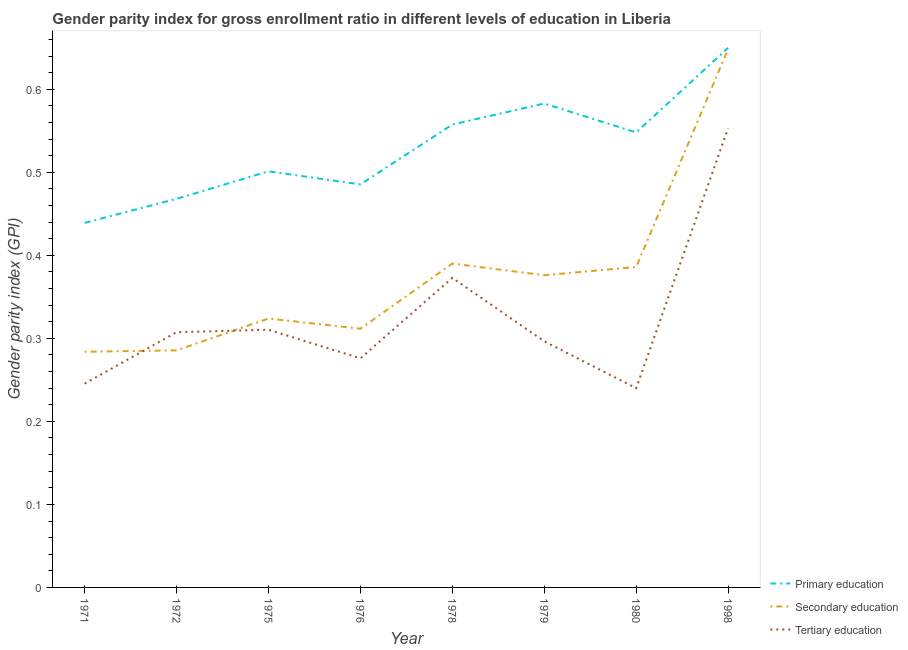Is the number of lines equal to the number of legend labels?
Offer a terse response. Yes. What is the gender parity index in primary education in 1978?
Your answer should be very brief. 0.56. Across all years, what is the maximum gender parity index in primary education?
Ensure brevity in your answer.  0.65. Across all years, what is the minimum gender parity index in secondary education?
Provide a succinct answer. 0.28. In which year was the gender parity index in tertiary education maximum?
Give a very brief answer. 1998. What is the total gender parity index in secondary education in the graph?
Your answer should be very brief. 3.01. What is the difference between the gender parity index in primary education in 1975 and that in 1978?
Your answer should be compact. -0.06. What is the difference between the gender parity index in tertiary education in 1980 and the gender parity index in secondary education in 1975?
Keep it short and to the point. -0.08. What is the average gender parity index in tertiary education per year?
Give a very brief answer. 0.33. In the year 1972, what is the difference between the gender parity index in primary education and gender parity index in secondary education?
Offer a very short reply. 0.18. What is the ratio of the gender parity index in secondary education in 1972 to that in 1978?
Provide a succinct answer. 0.73. Is the difference between the gender parity index in tertiary education in 1975 and 1978 greater than the difference between the gender parity index in secondary education in 1975 and 1978?
Your answer should be compact. Yes. What is the difference between the highest and the second highest gender parity index in primary education?
Provide a succinct answer. 0.07. What is the difference between the highest and the lowest gender parity index in tertiary education?
Offer a very short reply. 0.31. In how many years, is the gender parity index in secondary education greater than the average gender parity index in secondary education taken over all years?
Offer a terse response. 4. Is the sum of the gender parity index in primary education in 1972 and 1978 greater than the maximum gender parity index in tertiary education across all years?
Your answer should be compact. Yes. Is the gender parity index in secondary education strictly greater than the gender parity index in primary education over the years?
Give a very brief answer. No. Is the gender parity index in tertiary education strictly less than the gender parity index in primary education over the years?
Your answer should be compact. Yes. Does the graph contain any zero values?
Your answer should be very brief. No. Where does the legend appear in the graph?
Give a very brief answer. Bottom right. How many legend labels are there?
Ensure brevity in your answer.  3. What is the title of the graph?
Ensure brevity in your answer.  Gender parity index for gross enrollment ratio in different levels of education in Liberia. Does "Other sectors" appear as one of the legend labels in the graph?
Offer a very short reply. No. What is the label or title of the Y-axis?
Offer a terse response. Gender parity index (GPI). What is the Gender parity index (GPI) of Primary education in 1971?
Make the answer very short. 0.44. What is the Gender parity index (GPI) of Secondary education in 1971?
Provide a short and direct response. 0.28. What is the Gender parity index (GPI) in Tertiary education in 1971?
Offer a terse response. 0.25. What is the Gender parity index (GPI) of Primary education in 1972?
Offer a very short reply. 0.47. What is the Gender parity index (GPI) of Secondary education in 1972?
Provide a short and direct response. 0.29. What is the Gender parity index (GPI) in Tertiary education in 1972?
Your answer should be compact. 0.31. What is the Gender parity index (GPI) of Primary education in 1975?
Make the answer very short. 0.5. What is the Gender parity index (GPI) of Secondary education in 1975?
Your answer should be very brief. 0.32. What is the Gender parity index (GPI) of Tertiary education in 1975?
Provide a succinct answer. 0.31. What is the Gender parity index (GPI) of Primary education in 1976?
Ensure brevity in your answer.  0.49. What is the Gender parity index (GPI) of Secondary education in 1976?
Make the answer very short. 0.31. What is the Gender parity index (GPI) in Tertiary education in 1976?
Your answer should be very brief. 0.28. What is the Gender parity index (GPI) of Primary education in 1978?
Your answer should be very brief. 0.56. What is the Gender parity index (GPI) in Secondary education in 1978?
Keep it short and to the point. 0.39. What is the Gender parity index (GPI) of Tertiary education in 1978?
Make the answer very short. 0.37. What is the Gender parity index (GPI) of Primary education in 1979?
Make the answer very short. 0.58. What is the Gender parity index (GPI) of Secondary education in 1979?
Give a very brief answer. 0.38. What is the Gender parity index (GPI) of Tertiary education in 1979?
Ensure brevity in your answer.  0.3. What is the Gender parity index (GPI) in Primary education in 1980?
Provide a succinct answer. 0.55. What is the Gender parity index (GPI) of Secondary education in 1980?
Provide a short and direct response. 0.39. What is the Gender parity index (GPI) in Tertiary education in 1980?
Your response must be concise. 0.24. What is the Gender parity index (GPI) of Primary education in 1998?
Ensure brevity in your answer.  0.65. What is the Gender parity index (GPI) of Secondary education in 1998?
Provide a short and direct response. 0.65. What is the Gender parity index (GPI) of Tertiary education in 1998?
Keep it short and to the point. 0.55. Across all years, what is the maximum Gender parity index (GPI) of Primary education?
Offer a very short reply. 0.65. Across all years, what is the maximum Gender parity index (GPI) in Secondary education?
Ensure brevity in your answer.  0.65. Across all years, what is the maximum Gender parity index (GPI) in Tertiary education?
Your answer should be very brief. 0.55. Across all years, what is the minimum Gender parity index (GPI) in Primary education?
Give a very brief answer. 0.44. Across all years, what is the minimum Gender parity index (GPI) in Secondary education?
Ensure brevity in your answer.  0.28. Across all years, what is the minimum Gender parity index (GPI) of Tertiary education?
Offer a very short reply. 0.24. What is the total Gender parity index (GPI) in Primary education in the graph?
Make the answer very short. 4.23. What is the total Gender parity index (GPI) of Secondary education in the graph?
Offer a very short reply. 3.01. What is the total Gender parity index (GPI) in Tertiary education in the graph?
Ensure brevity in your answer.  2.6. What is the difference between the Gender parity index (GPI) of Primary education in 1971 and that in 1972?
Your response must be concise. -0.03. What is the difference between the Gender parity index (GPI) of Secondary education in 1971 and that in 1972?
Provide a succinct answer. -0. What is the difference between the Gender parity index (GPI) in Tertiary education in 1971 and that in 1972?
Your answer should be very brief. -0.06. What is the difference between the Gender parity index (GPI) of Primary education in 1971 and that in 1975?
Your answer should be very brief. -0.06. What is the difference between the Gender parity index (GPI) in Secondary education in 1971 and that in 1975?
Provide a short and direct response. -0.04. What is the difference between the Gender parity index (GPI) of Tertiary education in 1971 and that in 1975?
Offer a terse response. -0.06. What is the difference between the Gender parity index (GPI) in Primary education in 1971 and that in 1976?
Give a very brief answer. -0.05. What is the difference between the Gender parity index (GPI) in Secondary education in 1971 and that in 1976?
Your answer should be very brief. -0.03. What is the difference between the Gender parity index (GPI) of Tertiary education in 1971 and that in 1976?
Offer a very short reply. -0.03. What is the difference between the Gender parity index (GPI) of Primary education in 1971 and that in 1978?
Your response must be concise. -0.12. What is the difference between the Gender parity index (GPI) of Secondary education in 1971 and that in 1978?
Offer a terse response. -0.11. What is the difference between the Gender parity index (GPI) in Tertiary education in 1971 and that in 1978?
Ensure brevity in your answer.  -0.13. What is the difference between the Gender parity index (GPI) of Primary education in 1971 and that in 1979?
Your answer should be compact. -0.14. What is the difference between the Gender parity index (GPI) of Secondary education in 1971 and that in 1979?
Your response must be concise. -0.09. What is the difference between the Gender parity index (GPI) of Tertiary education in 1971 and that in 1979?
Provide a short and direct response. -0.05. What is the difference between the Gender parity index (GPI) in Primary education in 1971 and that in 1980?
Keep it short and to the point. -0.11. What is the difference between the Gender parity index (GPI) in Secondary education in 1971 and that in 1980?
Ensure brevity in your answer.  -0.1. What is the difference between the Gender parity index (GPI) of Tertiary education in 1971 and that in 1980?
Ensure brevity in your answer.  0.01. What is the difference between the Gender parity index (GPI) of Primary education in 1971 and that in 1998?
Your response must be concise. -0.21. What is the difference between the Gender parity index (GPI) in Secondary education in 1971 and that in 1998?
Provide a short and direct response. -0.36. What is the difference between the Gender parity index (GPI) of Tertiary education in 1971 and that in 1998?
Give a very brief answer. -0.31. What is the difference between the Gender parity index (GPI) in Primary education in 1972 and that in 1975?
Provide a succinct answer. -0.03. What is the difference between the Gender parity index (GPI) of Secondary education in 1972 and that in 1975?
Your response must be concise. -0.04. What is the difference between the Gender parity index (GPI) of Tertiary education in 1972 and that in 1975?
Ensure brevity in your answer.  -0. What is the difference between the Gender parity index (GPI) in Primary education in 1972 and that in 1976?
Offer a very short reply. -0.02. What is the difference between the Gender parity index (GPI) of Secondary education in 1972 and that in 1976?
Offer a very short reply. -0.03. What is the difference between the Gender parity index (GPI) in Tertiary education in 1972 and that in 1976?
Your response must be concise. 0.03. What is the difference between the Gender parity index (GPI) in Primary education in 1972 and that in 1978?
Provide a succinct answer. -0.09. What is the difference between the Gender parity index (GPI) in Secondary education in 1972 and that in 1978?
Make the answer very short. -0.1. What is the difference between the Gender parity index (GPI) of Tertiary education in 1972 and that in 1978?
Give a very brief answer. -0.07. What is the difference between the Gender parity index (GPI) in Primary education in 1972 and that in 1979?
Provide a short and direct response. -0.11. What is the difference between the Gender parity index (GPI) of Secondary education in 1972 and that in 1979?
Make the answer very short. -0.09. What is the difference between the Gender parity index (GPI) in Tertiary education in 1972 and that in 1979?
Provide a short and direct response. 0.01. What is the difference between the Gender parity index (GPI) in Primary education in 1972 and that in 1980?
Make the answer very short. -0.08. What is the difference between the Gender parity index (GPI) in Secondary education in 1972 and that in 1980?
Provide a short and direct response. -0.1. What is the difference between the Gender parity index (GPI) of Tertiary education in 1972 and that in 1980?
Offer a very short reply. 0.07. What is the difference between the Gender parity index (GPI) in Primary education in 1972 and that in 1998?
Keep it short and to the point. -0.18. What is the difference between the Gender parity index (GPI) of Secondary education in 1972 and that in 1998?
Give a very brief answer. -0.36. What is the difference between the Gender parity index (GPI) of Tertiary education in 1972 and that in 1998?
Make the answer very short. -0.25. What is the difference between the Gender parity index (GPI) in Primary education in 1975 and that in 1976?
Your response must be concise. 0.02. What is the difference between the Gender parity index (GPI) of Secondary education in 1975 and that in 1976?
Offer a terse response. 0.01. What is the difference between the Gender parity index (GPI) of Tertiary education in 1975 and that in 1976?
Your response must be concise. 0.03. What is the difference between the Gender parity index (GPI) in Primary education in 1975 and that in 1978?
Provide a short and direct response. -0.06. What is the difference between the Gender parity index (GPI) of Secondary education in 1975 and that in 1978?
Ensure brevity in your answer.  -0.07. What is the difference between the Gender parity index (GPI) in Tertiary education in 1975 and that in 1978?
Your response must be concise. -0.06. What is the difference between the Gender parity index (GPI) of Primary education in 1975 and that in 1979?
Your answer should be compact. -0.08. What is the difference between the Gender parity index (GPI) of Secondary education in 1975 and that in 1979?
Give a very brief answer. -0.05. What is the difference between the Gender parity index (GPI) of Tertiary education in 1975 and that in 1979?
Make the answer very short. 0.01. What is the difference between the Gender parity index (GPI) of Primary education in 1975 and that in 1980?
Your answer should be compact. -0.05. What is the difference between the Gender parity index (GPI) of Secondary education in 1975 and that in 1980?
Keep it short and to the point. -0.06. What is the difference between the Gender parity index (GPI) of Tertiary education in 1975 and that in 1980?
Offer a very short reply. 0.07. What is the difference between the Gender parity index (GPI) of Primary education in 1975 and that in 1998?
Ensure brevity in your answer.  -0.15. What is the difference between the Gender parity index (GPI) in Secondary education in 1975 and that in 1998?
Offer a very short reply. -0.32. What is the difference between the Gender parity index (GPI) in Tertiary education in 1975 and that in 1998?
Offer a terse response. -0.24. What is the difference between the Gender parity index (GPI) in Primary education in 1976 and that in 1978?
Your answer should be compact. -0.07. What is the difference between the Gender parity index (GPI) of Secondary education in 1976 and that in 1978?
Your answer should be compact. -0.08. What is the difference between the Gender parity index (GPI) of Tertiary education in 1976 and that in 1978?
Your answer should be compact. -0.1. What is the difference between the Gender parity index (GPI) of Primary education in 1976 and that in 1979?
Ensure brevity in your answer.  -0.1. What is the difference between the Gender parity index (GPI) in Secondary education in 1976 and that in 1979?
Offer a terse response. -0.06. What is the difference between the Gender parity index (GPI) in Tertiary education in 1976 and that in 1979?
Your answer should be very brief. -0.02. What is the difference between the Gender parity index (GPI) of Primary education in 1976 and that in 1980?
Give a very brief answer. -0.06. What is the difference between the Gender parity index (GPI) in Secondary education in 1976 and that in 1980?
Your answer should be compact. -0.07. What is the difference between the Gender parity index (GPI) of Tertiary education in 1976 and that in 1980?
Provide a succinct answer. 0.04. What is the difference between the Gender parity index (GPI) in Primary education in 1976 and that in 1998?
Provide a short and direct response. -0.16. What is the difference between the Gender parity index (GPI) in Secondary education in 1976 and that in 1998?
Keep it short and to the point. -0.34. What is the difference between the Gender parity index (GPI) in Tertiary education in 1976 and that in 1998?
Provide a short and direct response. -0.28. What is the difference between the Gender parity index (GPI) in Primary education in 1978 and that in 1979?
Ensure brevity in your answer.  -0.03. What is the difference between the Gender parity index (GPI) of Secondary education in 1978 and that in 1979?
Offer a very short reply. 0.01. What is the difference between the Gender parity index (GPI) of Tertiary education in 1978 and that in 1979?
Provide a succinct answer. 0.08. What is the difference between the Gender parity index (GPI) of Primary education in 1978 and that in 1980?
Your answer should be very brief. 0.01. What is the difference between the Gender parity index (GPI) in Secondary education in 1978 and that in 1980?
Ensure brevity in your answer.  0. What is the difference between the Gender parity index (GPI) of Tertiary education in 1978 and that in 1980?
Offer a very short reply. 0.13. What is the difference between the Gender parity index (GPI) in Primary education in 1978 and that in 1998?
Provide a succinct answer. -0.09. What is the difference between the Gender parity index (GPI) in Secondary education in 1978 and that in 1998?
Keep it short and to the point. -0.26. What is the difference between the Gender parity index (GPI) in Tertiary education in 1978 and that in 1998?
Provide a succinct answer. -0.18. What is the difference between the Gender parity index (GPI) in Primary education in 1979 and that in 1980?
Provide a short and direct response. 0.03. What is the difference between the Gender parity index (GPI) of Secondary education in 1979 and that in 1980?
Give a very brief answer. -0.01. What is the difference between the Gender parity index (GPI) in Tertiary education in 1979 and that in 1980?
Provide a succinct answer. 0.06. What is the difference between the Gender parity index (GPI) in Primary education in 1979 and that in 1998?
Make the answer very short. -0.07. What is the difference between the Gender parity index (GPI) in Secondary education in 1979 and that in 1998?
Give a very brief answer. -0.27. What is the difference between the Gender parity index (GPI) in Tertiary education in 1979 and that in 1998?
Keep it short and to the point. -0.26. What is the difference between the Gender parity index (GPI) in Primary education in 1980 and that in 1998?
Your response must be concise. -0.1. What is the difference between the Gender parity index (GPI) in Secondary education in 1980 and that in 1998?
Your response must be concise. -0.26. What is the difference between the Gender parity index (GPI) of Tertiary education in 1980 and that in 1998?
Your answer should be very brief. -0.31. What is the difference between the Gender parity index (GPI) in Primary education in 1971 and the Gender parity index (GPI) in Secondary education in 1972?
Ensure brevity in your answer.  0.15. What is the difference between the Gender parity index (GPI) in Primary education in 1971 and the Gender parity index (GPI) in Tertiary education in 1972?
Give a very brief answer. 0.13. What is the difference between the Gender parity index (GPI) of Secondary education in 1971 and the Gender parity index (GPI) of Tertiary education in 1972?
Your response must be concise. -0.02. What is the difference between the Gender parity index (GPI) of Primary education in 1971 and the Gender parity index (GPI) of Secondary education in 1975?
Provide a succinct answer. 0.12. What is the difference between the Gender parity index (GPI) in Primary education in 1971 and the Gender parity index (GPI) in Tertiary education in 1975?
Offer a very short reply. 0.13. What is the difference between the Gender parity index (GPI) of Secondary education in 1971 and the Gender parity index (GPI) of Tertiary education in 1975?
Your answer should be compact. -0.03. What is the difference between the Gender parity index (GPI) in Primary education in 1971 and the Gender parity index (GPI) in Secondary education in 1976?
Give a very brief answer. 0.13. What is the difference between the Gender parity index (GPI) of Primary education in 1971 and the Gender parity index (GPI) of Tertiary education in 1976?
Offer a terse response. 0.16. What is the difference between the Gender parity index (GPI) in Secondary education in 1971 and the Gender parity index (GPI) in Tertiary education in 1976?
Keep it short and to the point. 0.01. What is the difference between the Gender parity index (GPI) in Primary education in 1971 and the Gender parity index (GPI) in Secondary education in 1978?
Your answer should be compact. 0.05. What is the difference between the Gender parity index (GPI) in Primary education in 1971 and the Gender parity index (GPI) in Tertiary education in 1978?
Your answer should be compact. 0.07. What is the difference between the Gender parity index (GPI) of Secondary education in 1971 and the Gender parity index (GPI) of Tertiary education in 1978?
Your answer should be very brief. -0.09. What is the difference between the Gender parity index (GPI) of Primary education in 1971 and the Gender parity index (GPI) of Secondary education in 1979?
Offer a terse response. 0.06. What is the difference between the Gender parity index (GPI) in Primary education in 1971 and the Gender parity index (GPI) in Tertiary education in 1979?
Give a very brief answer. 0.14. What is the difference between the Gender parity index (GPI) of Secondary education in 1971 and the Gender parity index (GPI) of Tertiary education in 1979?
Keep it short and to the point. -0.01. What is the difference between the Gender parity index (GPI) in Primary education in 1971 and the Gender parity index (GPI) in Secondary education in 1980?
Provide a short and direct response. 0.05. What is the difference between the Gender parity index (GPI) of Primary education in 1971 and the Gender parity index (GPI) of Tertiary education in 1980?
Your response must be concise. 0.2. What is the difference between the Gender parity index (GPI) of Secondary education in 1971 and the Gender parity index (GPI) of Tertiary education in 1980?
Your response must be concise. 0.04. What is the difference between the Gender parity index (GPI) in Primary education in 1971 and the Gender parity index (GPI) in Secondary education in 1998?
Your response must be concise. -0.21. What is the difference between the Gender parity index (GPI) in Primary education in 1971 and the Gender parity index (GPI) in Tertiary education in 1998?
Provide a succinct answer. -0.11. What is the difference between the Gender parity index (GPI) in Secondary education in 1971 and the Gender parity index (GPI) in Tertiary education in 1998?
Keep it short and to the point. -0.27. What is the difference between the Gender parity index (GPI) in Primary education in 1972 and the Gender parity index (GPI) in Secondary education in 1975?
Give a very brief answer. 0.14. What is the difference between the Gender parity index (GPI) in Primary education in 1972 and the Gender parity index (GPI) in Tertiary education in 1975?
Give a very brief answer. 0.16. What is the difference between the Gender parity index (GPI) in Secondary education in 1972 and the Gender parity index (GPI) in Tertiary education in 1975?
Offer a very short reply. -0.02. What is the difference between the Gender parity index (GPI) of Primary education in 1972 and the Gender parity index (GPI) of Secondary education in 1976?
Your answer should be very brief. 0.16. What is the difference between the Gender parity index (GPI) in Primary education in 1972 and the Gender parity index (GPI) in Tertiary education in 1976?
Your answer should be very brief. 0.19. What is the difference between the Gender parity index (GPI) of Secondary education in 1972 and the Gender parity index (GPI) of Tertiary education in 1976?
Ensure brevity in your answer.  0.01. What is the difference between the Gender parity index (GPI) in Primary education in 1972 and the Gender parity index (GPI) in Secondary education in 1978?
Offer a terse response. 0.08. What is the difference between the Gender parity index (GPI) of Primary education in 1972 and the Gender parity index (GPI) of Tertiary education in 1978?
Make the answer very short. 0.1. What is the difference between the Gender parity index (GPI) of Secondary education in 1972 and the Gender parity index (GPI) of Tertiary education in 1978?
Provide a succinct answer. -0.09. What is the difference between the Gender parity index (GPI) in Primary education in 1972 and the Gender parity index (GPI) in Secondary education in 1979?
Ensure brevity in your answer.  0.09. What is the difference between the Gender parity index (GPI) in Primary education in 1972 and the Gender parity index (GPI) in Tertiary education in 1979?
Make the answer very short. 0.17. What is the difference between the Gender parity index (GPI) of Secondary education in 1972 and the Gender parity index (GPI) of Tertiary education in 1979?
Your response must be concise. -0.01. What is the difference between the Gender parity index (GPI) of Primary education in 1972 and the Gender parity index (GPI) of Secondary education in 1980?
Give a very brief answer. 0.08. What is the difference between the Gender parity index (GPI) of Primary education in 1972 and the Gender parity index (GPI) of Tertiary education in 1980?
Offer a terse response. 0.23. What is the difference between the Gender parity index (GPI) of Secondary education in 1972 and the Gender parity index (GPI) of Tertiary education in 1980?
Offer a terse response. 0.05. What is the difference between the Gender parity index (GPI) of Primary education in 1972 and the Gender parity index (GPI) of Secondary education in 1998?
Your answer should be very brief. -0.18. What is the difference between the Gender parity index (GPI) of Primary education in 1972 and the Gender parity index (GPI) of Tertiary education in 1998?
Your response must be concise. -0.09. What is the difference between the Gender parity index (GPI) in Secondary education in 1972 and the Gender parity index (GPI) in Tertiary education in 1998?
Provide a succinct answer. -0.27. What is the difference between the Gender parity index (GPI) in Primary education in 1975 and the Gender parity index (GPI) in Secondary education in 1976?
Your response must be concise. 0.19. What is the difference between the Gender parity index (GPI) of Primary education in 1975 and the Gender parity index (GPI) of Tertiary education in 1976?
Provide a short and direct response. 0.23. What is the difference between the Gender parity index (GPI) of Secondary education in 1975 and the Gender parity index (GPI) of Tertiary education in 1976?
Keep it short and to the point. 0.05. What is the difference between the Gender parity index (GPI) in Primary education in 1975 and the Gender parity index (GPI) in Secondary education in 1978?
Offer a terse response. 0.11. What is the difference between the Gender parity index (GPI) of Primary education in 1975 and the Gender parity index (GPI) of Tertiary education in 1978?
Keep it short and to the point. 0.13. What is the difference between the Gender parity index (GPI) in Secondary education in 1975 and the Gender parity index (GPI) in Tertiary education in 1978?
Your answer should be very brief. -0.05. What is the difference between the Gender parity index (GPI) of Primary education in 1975 and the Gender parity index (GPI) of Secondary education in 1979?
Keep it short and to the point. 0.13. What is the difference between the Gender parity index (GPI) in Primary education in 1975 and the Gender parity index (GPI) in Tertiary education in 1979?
Ensure brevity in your answer.  0.2. What is the difference between the Gender parity index (GPI) of Secondary education in 1975 and the Gender parity index (GPI) of Tertiary education in 1979?
Your answer should be very brief. 0.03. What is the difference between the Gender parity index (GPI) of Primary education in 1975 and the Gender parity index (GPI) of Secondary education in 1980?
Offer a very short reply. 0.12. What is the difference between the Gender parity index (GPI) of Primary education in 1975 and the Gender parity index (GPI) of Tertiary education in 1980?
Your answer should be compact. 0.26. What is the difference between the Gender parity index (GPI) of Secondary education in 1975 and the Gender parity index (GPI) of Tertiary education in 1980?
Provide a succinct answer. 0.08. What is the difference between the Gender parity index (GPI) of Primary education in 1975 and the Gender parity index (GPI) of Secondary education in 1998?
Offer a terse response. -0.15. What is the difference between the Gender parity index (GPI) in Primary education in 1975 and the Gender parity index (GPI) in Tertiary education in 1998?
Your answer should be compact. -0.05. What is the difference between the Gender parity index (GPI) in Secondary education in 1975 and the Gender parity index (GPI) in Tertiary education in 1998?
Your response must be concise. -0.23. What is the difference between the Gender parity index (GPI) of Primary education in 1976 and the Gender parity index (GPI) of Secondary education in 1978?
Your answer should be very brief. 0.1. What is the difference between the Gender parity index (GPI) in Primary education in 1976 and the Gender parity index (GPI) in Tertiary education in 1978?
Provide a succinct answer. 0.11. What is the difference between the Gender parity index (GPI) of Secondary education in 1976 and the Gender parity index (GPI) of Tertiary education in 1978?
Your answer should be very brief. -0.06. What is the difference between the Gender parity index (GPI) of Primary education in 1976 and the Gender parity index (GPI) of Secondary education in 1979?
Your answer should be compact. 0.11. What is the difference between the Gender parity index (GPI) in Primary education in 1976 and the Gender parity index (GPI) in Tertiary education in 1979?
Ensure brevity in your answer.  0.19. What is the difference between the Gender parity index (GPI) of Secondary education in 1976 and the Gender parity index (GPI) of Tertiary education in 1979?
Your answer should be compact. 0.02. What is the difference between the Gender parity index (GPI) in Primary education in 1976 and the Gender parity index (GPI) in Secondary education in 1980?
Make the answer very short. 0.1. What is the difference between the Gender parity index (GPI) of Primary education in 1976 and the Gender parity index (GPI) of Tertiary education in 1980?
Your answer should be compact. 0.25. What is the difference between the Gender parity index (GPI) of Secondary education in 1976 and the Gender parity index (GPI) of Tertiary education in 1980?
Your answer should be compact. 0.07. What is the difference between the Gender parity index (GPI) of Primary education in 1976 and the Gender parity index (GPI) of Secondary education in 1998?
Your answer should be compact. -0.16. What is the difference between the Gender parity index (GPI) in Primary education in 1976 and the Gender parity index (GPI) in Tertiary education in 1998?
Your answer should be very brief. -0.07. What is the difference between the Gender parity index (GPI) of Secondary education in 1976 and the Gender parity index (GPI) of Tertiary education in 1998?
Offer a very short reply. -0.24. What is the difference between the Gender parity index (GPI) of Primary education in 1978 and the Gender parity index (GPI) of Secondary education in 1979?
Your answer should be very brief. 0.18. What is the difference between the Gender parity index (GPI) of Primary education in 1978 and the Gender parity index (GPI) of Tertiary education in 1979?
Keep it short and to the point. 0.26. What is the difference between the Gender parity index (GPI) in Secondary education in 1978 and the Gender parity index (GPI) in Tertiary education in 1979?
Your answer should be very brief. 0.09. What is the difference between the Gender parity index (GPI) of Primary education in 1978 and the Gender parity index (GPI) of Secondary education in 1980?
Provide a short and direct response. 0.17. What is the difference between the Gender parity index (GPI) in Primary education in 1978 and the Gender parity index (GPI) in Tertiary education in 1980?
Offer a terse response. 0.32. What is the difference between the Gender parity index (GPI) of Secondary education in 1978 and the Gender parity index (GPI) of Tertiary education in 1980?
Your answer should be very brief. 0.15. What is the difference between the Gender parity index (GPI) of Primary education in 1978 and the Gender parity index (GPI) of Secondary education in 1998?
Offer a terse response. -0.09. What is the difference between the Gender parity index (GPI) of Primary education in 1978 and the Gender parity index (GPI) of Tertiary education in 1998?
Give a very brief answer. 0. What is the difference between the Gender parity index (GPI) of Secondary education in 1978 and the Gender parity index (GPI) of Tertiary education in 1998?
Give a very brief answer. -0.16. What is the difference between the Gender parity index (GPI) of Primary education in 1979 and the Gender parity index (GPI) of Secondary education in 1980?
Provide a succinct answer. 0.2. What is the difference between the Gender parity index (GPI) in Primary education in 1979 and the Gender parity index (GPI) in Tertiary education in 1980?
Offer a very short reply. 0.34. What is the difference between the Gender parity index (GPI) in Secondary education in 1979 and the Gender parity index (GPI) in Tertiary education in 1980?
Your response must be concise. 0.14. What is the difference between the Gender parity index (GPI) in Primary education in 1979 and the Gender parity index (GPI) in Secondary education in 1998?
Offer a very short reply. -0.07. What is the difference between the Gender parity index (GPI) in Primary education in 1979 and the Gender parity index (GPI) in Tertiary education in 1998?
Your response must be concise. 0.03. What is the difference between the Gender parity index (GPI) in Secondary education in 1979 and the Gender parity index (GPI) in Tertiary education in 1998?
Offer a terse response. -0.18. What is the difference between the Gender parity index (GPI) of Primary education in 1980 and the Gender parity index (GPI) of Secondary education in 1998?
Offer a very short reply. -0.1. What is the difference between the Gender parity index (GPI) of Primary education in 1980 and the Gender parity index (GPI) of Tertiary education in 1998?
Offer a very short reply. -0.01. What is the difference between the Gender parity index (GPI) in Secondary education in 1980 and the Gender parity index (GPI) in Tertiary education in 1998?
Your response must be concise. -0.17. What is the average Gender parity index (GPI) of Primary education per year?
Your answer should be very brief. 0.53. What is the average Gender parity index (GPI) in Secondary education per year?
Your response must be concise. 0.38. What is the average Gender parity index (GPI) in Tertiary education per year?
Ensure brevity in your answer.  0.33. In the year 1971, what is the difference between the Gender parity index (GPI) in Primary education and Gender parity index (GPI) in Secondary education?
Your response must be concise. 0.16. In the year 1971, what is the difference between the Gender parity index (GPI) of Primary education and Gender parity index (GPI) of Tertiary education?
Your response must be concise. 0.19. In the year 1971, what is the difference between the Gender parity index (GPI) of Secondary education and Gender parity index (GPI) of Tertiary education?
Your answer should be very brief. 0.04. In the year 1972, what is the difference between the Gender parity index (GPI) in Primary education and Gender parity index (GPI) in Secondary education?
Ensure brevity in your answer.  0.18. In the year 1972, what is the difference between the Gender parity index (GPI) in Primary education and Gender parity index (GPI) in Tertiary education?
Your answer should be very brief. 0.16. In the year 1972, what is the difference between the Gender parity index (GPI) of Secondary education and Gender parity index (GPI) of Tertiary education?
Make the answer very short. -0.02. In the year 1975, what is the difference between the Gender parity index (GPI) in Primary education and Gender parity index (GPI) in Secondary education?
Make the answer very short. 0.18. In the year 1975, what is the difference between the Gender parity index (GPI) in Primary education and Gender parity index (GPI) in Tertiary education?
Your answer should be compact. 0.19. In the year 1975, what is the difference between the Gender parity index (GPI) in Secondary education and Gender parity index (GPI) in Tertiary education?
Ensure brevity in your answer.  0.01. In the year 1976, what is the difference between the Gender parity index (GPI) of Primary education and Gender parity index (GPI) of Secondary education?
Provide a succinct answer. 0.17. In the year 1976, what is the difference between the Gender parity index (GPI) in Primary education and Gender parity index (GPI) in Tertiary education?
Keep it short and to the point. 0.21. In the year 1976, what is the difference between the Gender parity index (GPI) of Secondary education and Gender parity index (GPI) of Tertiary education?
Make the answer very short. 0.04. In the year 1978, what is the difference between the Gender parity index (GPI) of Primary education and Gender parity index (GPI) of Secondary education?
Provide a succinct answer. 0.17. In the year 1978, what is the difference between the Gender parity index (GPI) in Primary education and Gender parity index (GPI) in Tertiary education?
Your answer should be compact. 0.18. In the year 1978, what is the difference between the Gender parity index (GPI) in Secondary education and Gender parity index (GPI) in Tertiary education?
Provide a succinct answer. 0.02. In the year 1979, what is the difference between the Gender parity index (GPI) of Primary education and Gender parity index (GPI) of Secondary education?
Offer a very short reply. 0.21. In the year 1979, what is the difference between the Gender parity index (GPI) of Primary education and Gender parity index (GPI) of Tertiary education?
Your response must be concise. 0.29. In the year 1979, what is the difference between the Gender parity index (GPI) of Secondary education and Gender parity index (GPI) of Tertiary education?
Offer a terse response. 0.08. In the year 1980, what is the difference between the Gender parity index (GPI) of Primary education and Gender parity index (GPI) of Secondary education?
Keep it short and to the point. 0.16. In the year 1980, what is the difference between the Gender parity index (GPI) of Primary education and Gender parity index (GPI) of Tertiary education?
Your answer should be very brief. 0.31. In the year 1980, what is the difference between the Gender parity index (GPI) in Secondary education and Gender parity index (GPI) in Tertiary education?
Provide a succinct answer. 0.15. In the year 1998, what is the difference between the Gender parity index (GPI) in Primary education and Gender parity index (GPI) in Secondary education?
Offer a very short reply. 0. In the year 1998, what is the difference between the Gender parity index (GPI) in Primary education and Gender parity index (GPI) in Tertiary education?
Make the answer very short. 0.1. In the year 1998, what is the difference between the Gender parity index (GPI) in Secondary education and Gender parity index (GPI) in Tertiary education?
Your response must be concise. 0.1. What is the ratio of the Gender parity index (GPI) in Primary education in 1971 to that in 1972?
Ensure brevity in your answer.  0.94. What is the ratio of the Gender parity index (GPI) of Tertiary education in 1971 to that in 1972?
Give a very brief answer. 0.8. What is the ratio of the Gender parity index (GPI) of Primary education in 1971 to that in 1975?
Give a very brief answer. 0.88. What is the ratio of the Gender parity index (GPI) of Secondary education in 1971 to that in 1975?
Keep it short and to the point. 0.88. What is the ratio of the Gender parity index (GPI) of Tertiary education in 1971 to that in 1975?
Your answer should be very brief. 0.79. What is the ratio of the Gender parity index (GPI) of Primary education in 1971 to that in 1976?
Give a very brief answer. 0.9. What is the ratio of the Gender parity index (GPI) in Secondary education in 1971 to that in 1976?
Offer a very short reply. 0.91. What is the ratio of the Gender parity index (GPI) in Tertiary education in 1971 to that in 1976?
Offer a very short reply. 0.89. What is the ratio of the Gender parity index (GPI) in Primary education in 1971 to that in 1978?
Make the answer very short. 0.79. What is the ratio of the Gender parity index (GPI) in Secondary education in 1971 to that in 1978?
Keep it short and to the point. 0.73. What is the ratio of the Gender parity index (GPI) of Tertiary education in 1971 to that in 1978?
Provide a succinct answer. 0.66. What is the ratio of the Gender parity index (GPI) in Primary education in 1971 to that in 1979?
Offer a terse response. 0.75. What is the ratio of the Gender parity index (GPI) in Secondary education in 1971 to that in 1979?
Make the answer very short. 0.75. What is the ratio of the Gender parity index (GPI) in Tertiary education in 1971 to that in 1979?
Offer a very short reply. 0.83. What is the ratio of the Gender parity index (GPI) in Primary education in 1971 to that in 1980?
Offer a very short reply. 0.8. What is the ratio of the Gender parity index (GPI) in Secondary education in 1971 to that in 1980?
Offer a very short reply. 0.74. What is the ratio of the Gender parity index (GPI) of Tertiary education in 1971 to that in 1980?
Your answer should be very brief. 1.02. What is the ratio of the Gender parity index (GPI) of Primary education in 1971 to that in 1998?
Your answer should be compact. 0.68. What is the ratio of the Gender parity index (GPI) of Secondary education in 1971 to that in 1998?
Provide a short and direct response. 0.44. What is the ratio of the Gender parity index (GPI) of Tertiary education in 1971 to that in 1998?
Provide a succinct answer. 0.44. What is the ratio of the Gender parity index (GPI) of Primary education in 1972 to that in 1975?
Provide a succinct answer. 0.93. What is the ratio of the Gender parity index (GPI) in Secondary education in 1972 to that in 1975?
Offer a terse response. 0.88. What is the ratio of the Gender parity index (GPI) of Tertiary education in 1972 to that in 1975?
Give a very brief answer. 0.99. What is the ratio of the Gender parity index (GPI) of Primary education in 1972 to that in 1976?
Your answer should be compact. 0.96. What is the ratio of the Gender parity index (GPI) in Secondary education in 1972 to that in 1976?
Your answer should be very brief. 0.92. What is the ratio of the Gender parity index (GPI) in Tertiary education in 1972 to that in 1976?
Ensure brevity in your answer.  1.11. What is the ratio of the Gender parity index (GPI) in Primary education in 1972 to that in 1978?
Keep it short and to the point. 0.84. What is the ratio of the Gender parity index (GPI) in Secondary education in 1972 to that in 1978?
Provide a succinct answer. 0.73. What is the ratio of the Gender parity index (GPI) of Tertiary education in 1972 to that in 1978?
Provide a short and direct response. 0.82. What is the ratio of the Gender parity index (GPI) of Primary education in 1972 to that in 1979?
Your answer should be very brief. 0.8. What is the ratio of the Gender parity index (GPI) of Secondary education in 1972 to that in 1979?
Ensure brevity in your answer.  0.76. What is the ratio of the Gender parity index (GPI) in Tertiary education in 1972 to that in 1979?
Your response must be concise. 1.04. What is the ratio of the Gender parity index (GPI) in Primary education in 1972 to that in 1980?
Your answer should be compact. 0.85. What is the ratio of the Gender parity index (GPI) of Secondary education in 1972 to that in 1980?
Ensure brevity in your answer.  0.74. What is the ratio of the Gender parity index (GPI) in Tertiary education in 1972 to that in 1980?
Make the answer very short. 1.28. What is the ratio of the Gender parity index (GPI) of Primary education in 1972 to that in 1998?
Your answer should be very brief. 0.72. What is the ratio of the Gender parity index (GPI) in Secondary education in 1972 to that in 1998?
Make the answer very short. 0.44. What is the ratio of the Gender parity index (GPI) in Tertiary education in 1972 to that in 1998?
Make the answer very short. 0.56. What is the ratio of the Gender parity index (GPI) of Primary education in 1975 to that in 1976?
Provide a short and direct response. 1.03. What is the ratio of the Gender parity index (GPI) in Secondary education in 1975 to that in 1976?
Your answer should be very brief. 1.04. What is the ratio of the Gender parity index (GPI) in Tertiary education in 1975 to that in 1976?
Keep it short and to the point. 1.12. What is the ratio of the Gender parity index (GPI) in Primary education in 1975 to that in 1978?
Your response must be concise. 0.9. What is the ratio of the Gender parity index (GPI) of Secondary education in 1975 to that in 1978?
Make the answer very short. 0.83. What is the ratio of the Gender parity index (GPI) in Tertiary education in 1975 to that in 1978?
Keep it short and to the point. 0.83. What is the ratio of the Gender parity index (GPI) in Primary education in 1975 to that in 1979?
Offer a terse response. 0.86. What is the ratio of the Gender parity index (GPI) in Secondary education in 1975 to that in 1979?
Your answer should be very brief. 0.86. What is the ratio of the Gender parity index (GPI) in Tertiary education in 1975 to that in 1979?
Your response must be concise. 1.05. What is the ratio of the Gender parity index (GPI) of Primary education in 1975 to that in 1980?
Offer a terse response. 0.91. What is the ratio of the Gender parity index (GPI) in Secondary education in 1975 to that in 1980?
Give a very brief answer. 0.84. What is the ratio of the Gender parity index (GPI) of Tertiary education in 1975 to that in 1980?
Give a very brief answer. 1.29. What is the ratio of the Gender parity index (GPI) of Primary education in 1975 to that in 1998?
Make the answer very short. 0.77. What is the ratio of the Gender parity index (GPI) in Secondary education in 1975 to that in 1998?
Make the answer very short. 0.5. What is the ratio of the Gender parity index (GPI) in Tertiary education in 1975 to that in 1998?
Provide a short and direct response. 0.56. What is the ratio of the Gender parity index (GPI) in Primary education in 1976 to that in 1978?
Your answer should be very brief. 0.87. What is the ratio of the Gender parity index (GPI) in Secondary education in 1976 to that in 1978?
Provide a succinct answer. 0.8. What is the ratio of the Gender parity index (GPI) in Tertiary education in 1976 to that in 1978?
Your response must be concise. 0.74. What is the ratio of the Gender parity index (GPI) of Primary education in 1976 to that in 1979?
Keep it short and to the point. 0.83. What is the ratio of the Gender parity index (GPI) in Secondary education in 1976 to that in 1979?
Your response must be concise. 0.83. What is the ratio of the Gender parity index (GPI) in Primary education in 1976 to that in 1980?
Ensure brevity in your answer.  0.89. What is the ratio of the Gender parity index (GPI) of Secondary education in 1976 to that in 1980?
Your answer should be compact. 0.81. What is the ratio of the Gender parity index (GPI) of Tertiary education in 1976 to that in 1980?
Keep it short and to the point. 1.15. What is the ratio of the Gender parity index (GPI) of Primary education in 1976 to that in 1998?
Your answer should be compact. 0.75. What is the ratio of the Gender parity index (GPI) of Secondary education in 1976 to that in 1998?
Your answer should be very brief. 0.48. What is the ratio of the Gender parity index (GPI) in Tertiary education in 1976 to that in 1998?
Your answer should be compact. 0.5. What is the ratio of the Gender parity index (GPI) of Primary education in 1978 to that in 1979?
Ensure brevity in your answer.  0.96. What is the ratio of the Gender parity index (GPI) in Secondary education in 1978 to that in 1979?
Your response must be concise. 1.04. What is the ratio of the Gender parity index (GPI) of Tertiary education in 1978 to that in 1979?
Your answer should be very brief. 1.26. What is the ratio of the Gender parity index (GPI) in Primary education in 1978 to that in 1980?
Ensure brevity in your answer.  1.02. What is the ratio of the Gender parity index (GPI) in Secondary education in 1978 to that in 1980?
Offer a terse response. 1.01. What is the ratio of the Gender parity index (GPI) in Tertiary education in 1978 to that in 1980?
Provide a succinct answer. 1.55. What is the ratio of the Gender parity index (GPI) of Primary education in 1978 to that in 1998?
Your answer should be very brief. 0.86. What is the ratio of the Gender parity index (GPI) in Secondary education in 1978 to that in 1998?
Provide a short and direct response. 0.6. What is the ratio of the Gender parity index (GPI) in Tertiary education in 1978 to that in 1998?
Your response must be concise. 0.67. What is the ratio of the Gender parity index (GPI) of Primary education in 1979 to that in 1980?
Provide a short and direct response. 1.06. What is the ratio of the Gender parity index (GPI) in Secondary education in 1979 to that in 1980?
Offer a very short reply. 0.97. What is the ratio of the Gender parity index (GPI) in Tertiary education in 1979 to that in 1980?
Keep it short and to the point. 1.24. What is the ratio of the Gender parity index (GPI) of Primary education in 1979 to that in 1998?
Provide a short and direct response. 0.9. What is the ratio of the Gender parity index (GPI) in Secondary education in 1979 to that in 1998?
Provide a short and direct response. 0.58. What is the ratio of the Gender parity index (GPI) in Tertiary education in 1979 to that in 1998?
Make the answer very short. 0.54. What is the ratio of the Gender parity index (GPI) in Primary education in 1980 to that in 1998?
Your answer should be compact. 0.84. What is the ratio of the Gender parity index (GPI) of Secondary education in 1980 to that in 1998?
Your response must be concise. 0.6. What is the ratio of the Gender parity index (GPI) in Tertiary education in 1980 to that in 1998?
Give a very brief answer. 0.43. What is the difference between the highest and the second highest Gender parity index (GPI) in Primary education?
Keep it short and to the point. 0.07. What is the difference between the highest and the second highest Gender parity index (GPI) in Secondary education?
Your answer should be compact. 0.26. What is the difference between the highest and the second highest Gender parity index (GPI) of Tertiary education?
Make the answer very short. 0.18. What is the difference between the highest and the lowest Gender parity index (GPI) of Primary education?
Your answer should be very brief. 0.21. What is the difference between the highest and the lowest Gender parity index (GPI) in Secondary education?
Provide a short and direct response. 0.36. What is the difference between the highest and the lowest Gender parity index (GPI) of Tertiary education?
Make the answer very short. 0.31. 